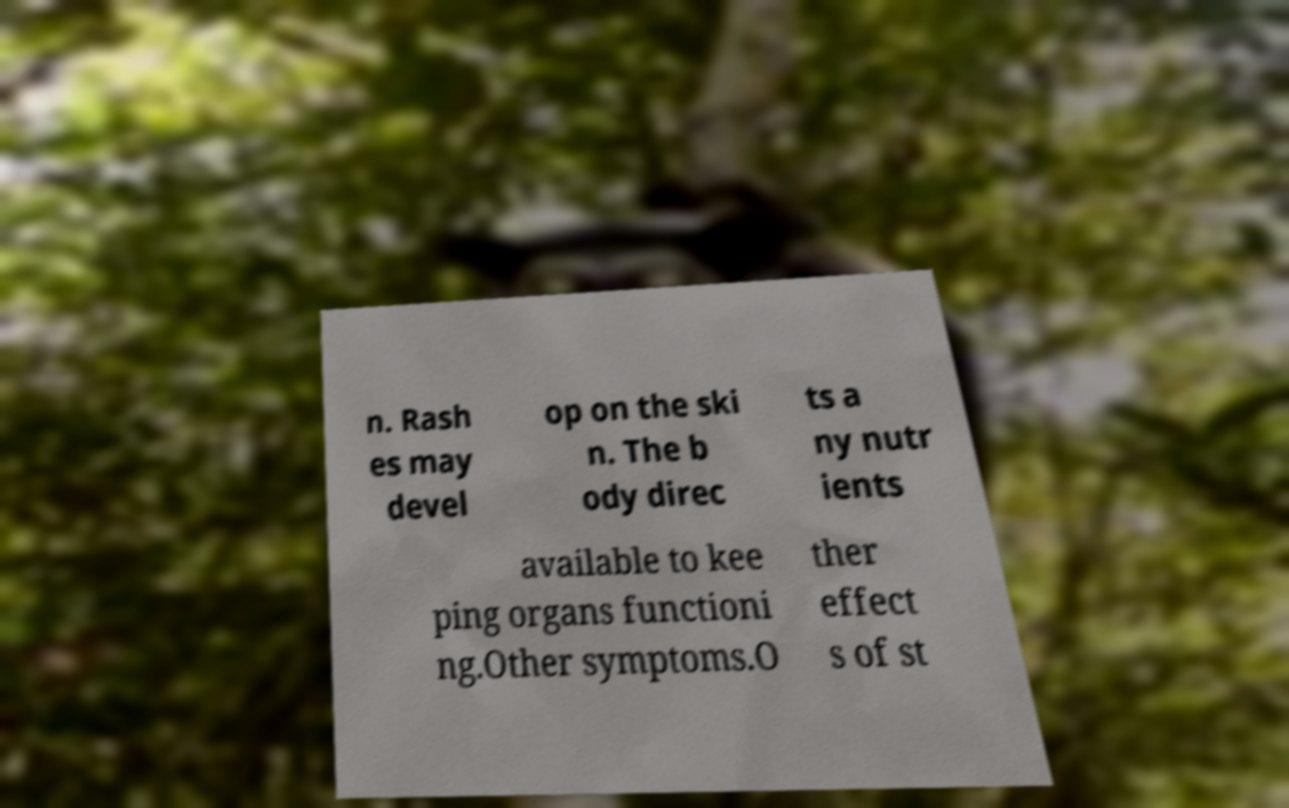Can you accurately transcribe the text from the provided image for me? n. Rash es may devel op on the ski n. The b ody direc ts a ny nutr ients available to kee ping organs functioni ng.Other symptoms.O ther effect s of st 